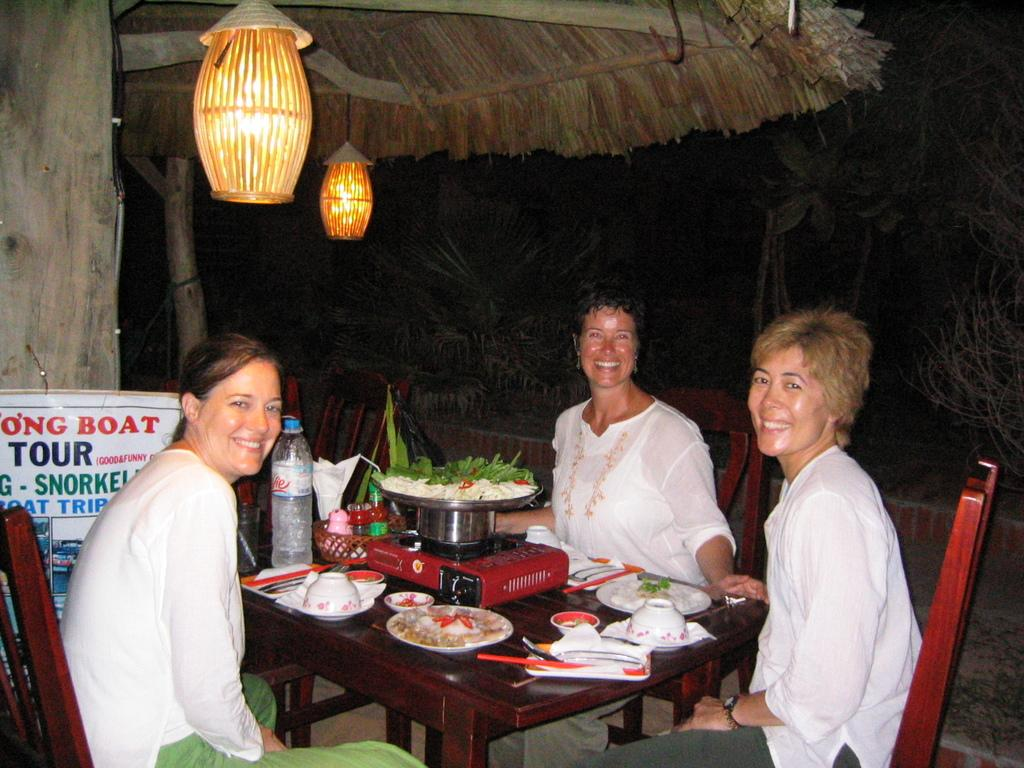How many women are present in the image? There are 3 women in the image. What are the women doing in the image? The women are sitting on chairs at a table. What can be found on the table with the women? There is a water bottle, food items, and cups on the table. What is visible in the background of the image? There is a banner, lights, and plants in the background of the image. What type of magic trick is the grandfather performing in the image? There is no grandfather or magic trick present in the image. What type of print can be seen on the cups in the image? The provided facts do not mention any specific print on the cups. 